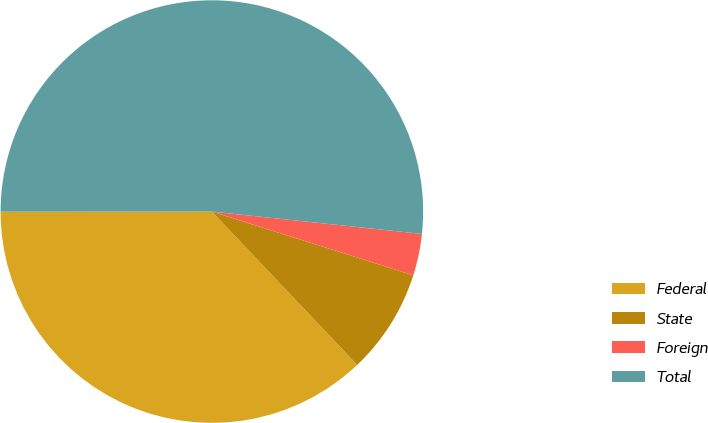<chart> <loc_0><loc_0><loc_500><loc_500><pie_chart><fcel>Federal<fcel>State<fcel>Foreign<fcel>Total<nl><fcel>37.06%<fcel>8.05%<fcel>3.19%<fcel>51.7%<nl></chart> 